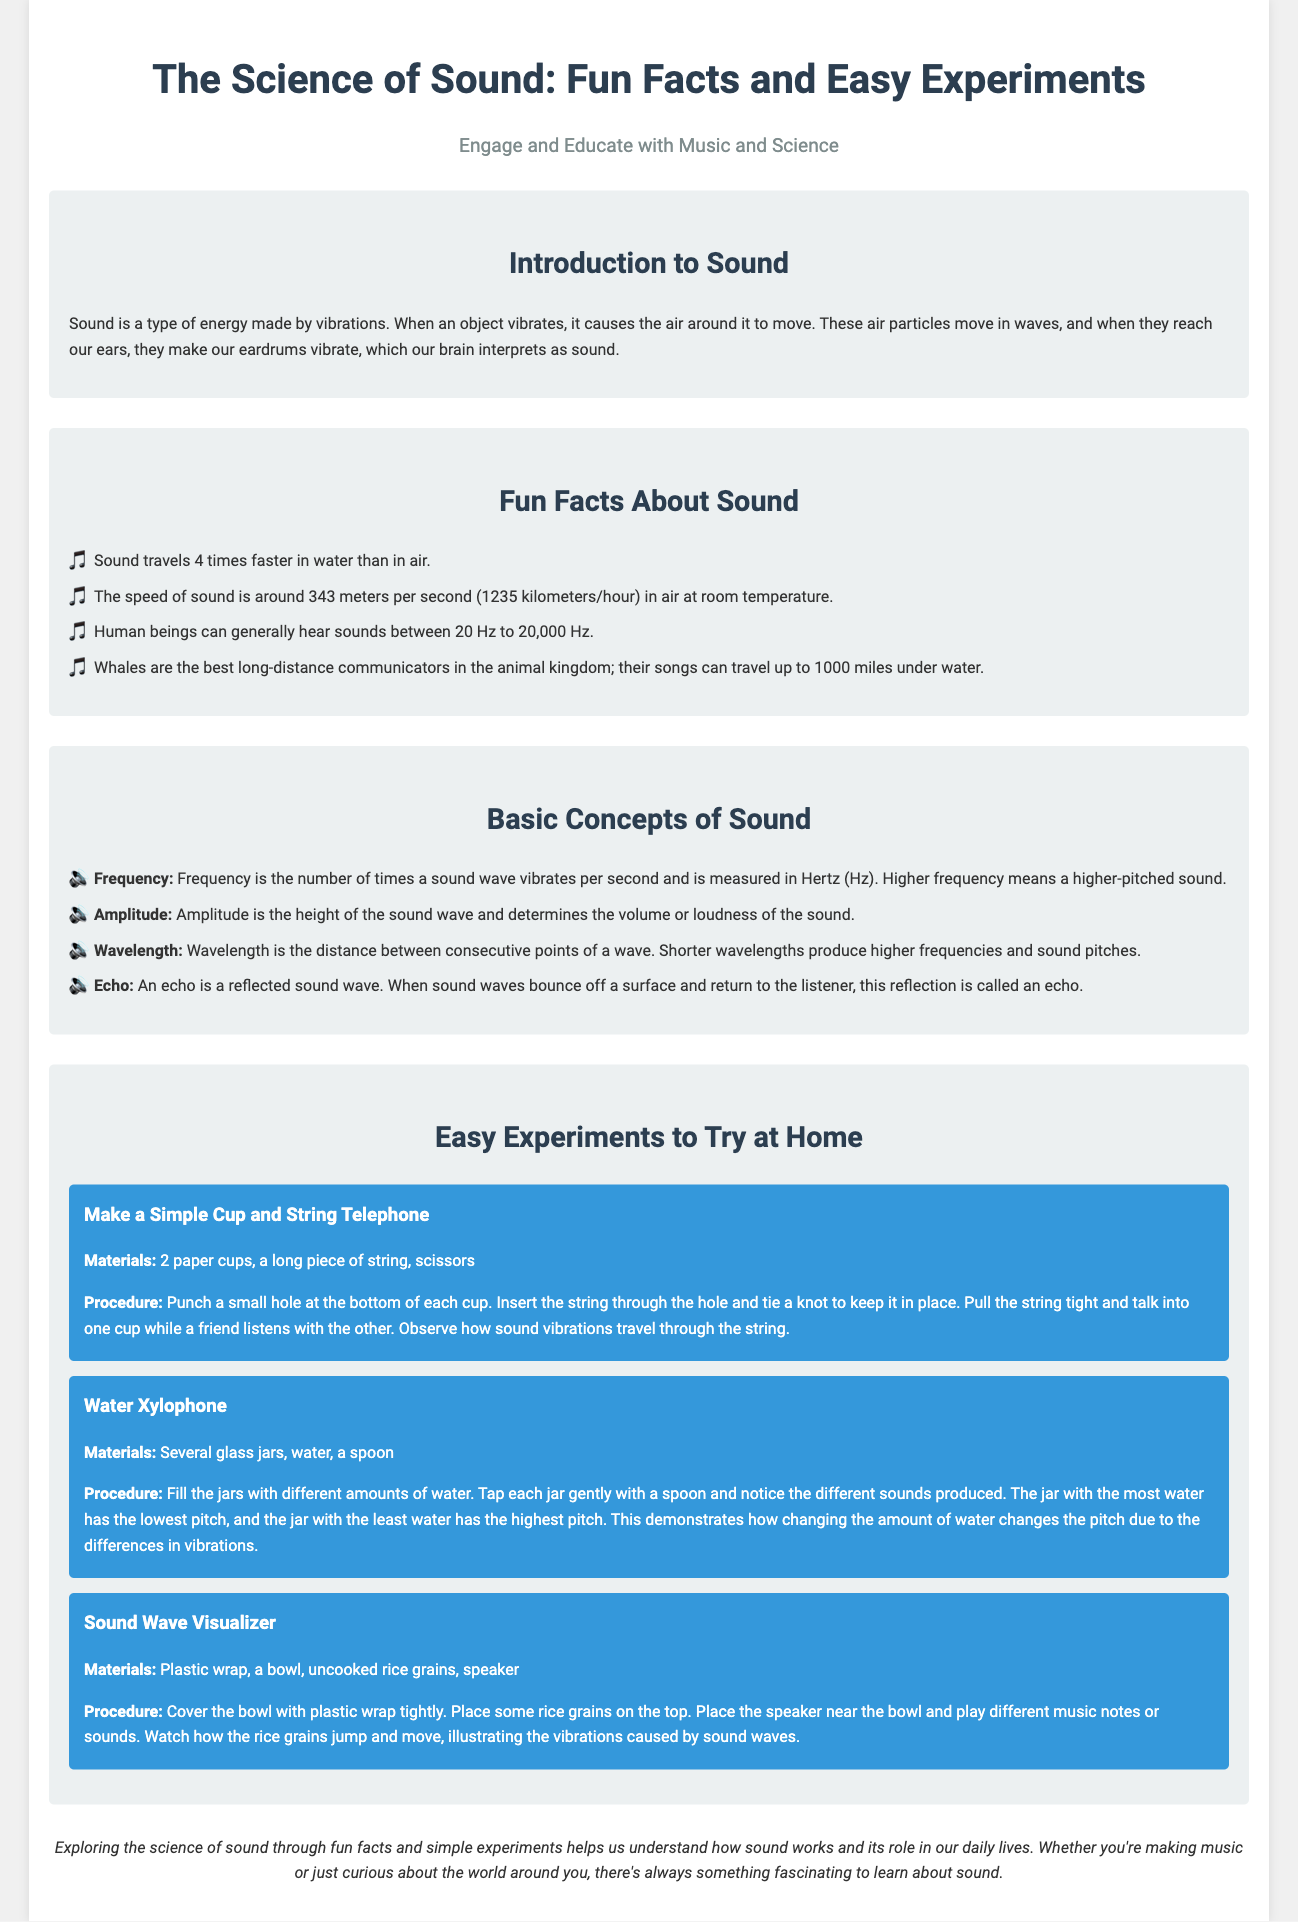What causes sound? Sound is caused by vibrations of objects, which create waves in the air.
Answer: Vibrations How fast does sound travel in air at room temperature? The speed of sound in air at room temperature is mentioned in the document.
Answer: 343 meters per second What do whales use to communicate long distances? The document states that whales communicate with something that can travel long distances underwater.
Answer: Songs What is the highest frequency humans can hear? The document provides the range of frequencies humans can hear.
Answer: 20,000 Hz What does the amplitude of a sound wave determine? The amplitude is related to a specific characteristic of sound, as mentioned in the document.
Answer: Volume Which experiment uses glass jars? The experiment involving glass jars illustrates a concept from the document.
Answer: Water Xylophone What is a reflected sound wave called? The document defines a specific term for a reflected sound wave.
Answer: Echo What happens to rice grains in the Sound Wave Visualizer experiment? The document describes the outcome of a specific experiment involving rice grains.
Answer: Jump and move 